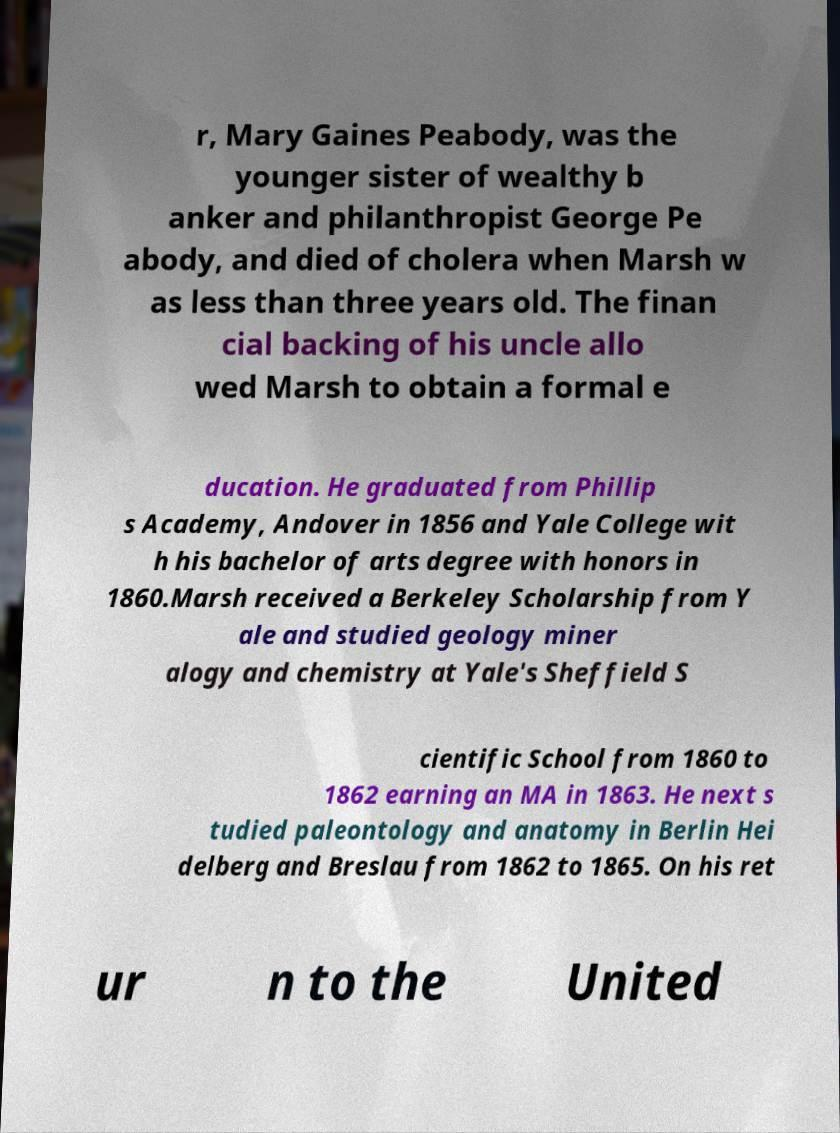There's text embedded in this image that I need extracted. Can you transcribe it verbatim? r, Mary Gaines Peabody, was the younger sister of wealthy b anker and philanthropist George Pe abody, and died of cholera when Marsh w as less than three years old. The finan cial backing of his uncle allo wed Marsh to obtain a formal e ducation. He graduated from Phillip s Academy, Andover in 1856 and Yale College wit h his bachelor of arts degree with honors in 1860.Marsh received a Berkeley Scholarship from Y ale and studied geology miner alogy and chemistry at Yale's Sheffield S cientific School from 1860 to 1862 earning an MA in 1863. He next s tudied paleontology and anatomy in Berlin Hei delberg and Breslau from 1862 to 1865. On his ret ur n to the United 